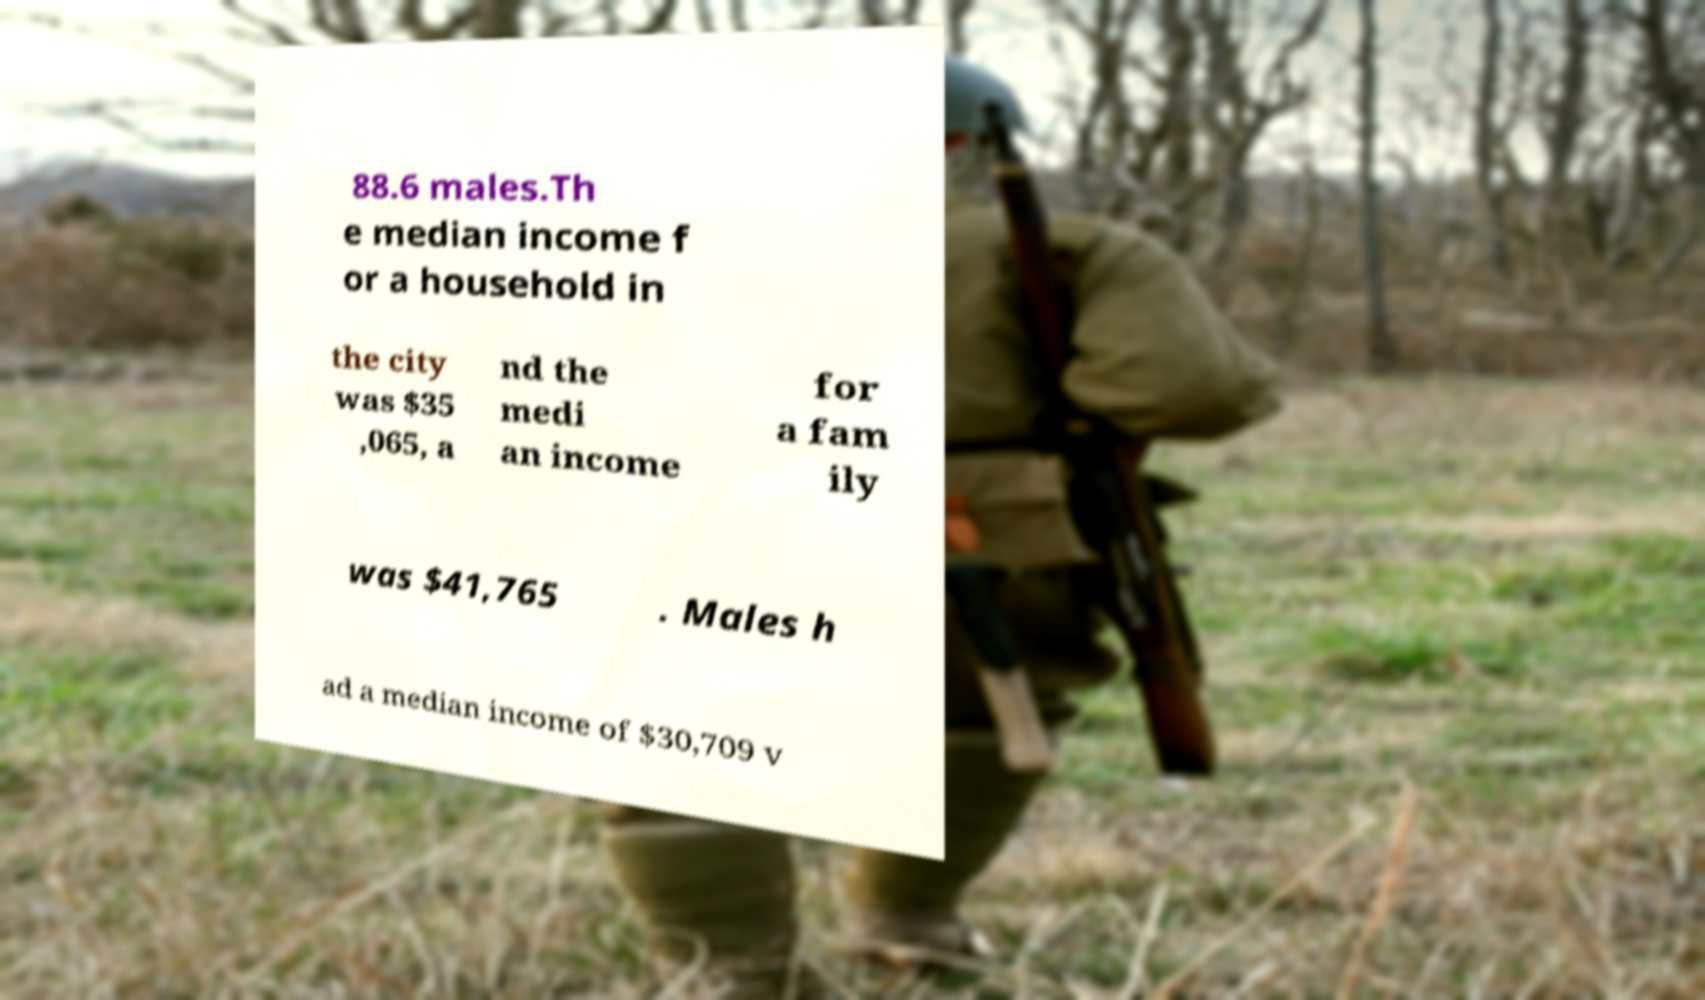What messages or text are displayed in this image? I need them in a readable, typed format. 88.6 males.Th e median income f or a household in the city was $35 ,065, a nd the medi an income for a fam ily was $41,765 . Males h ad a median income of $30,709 v 